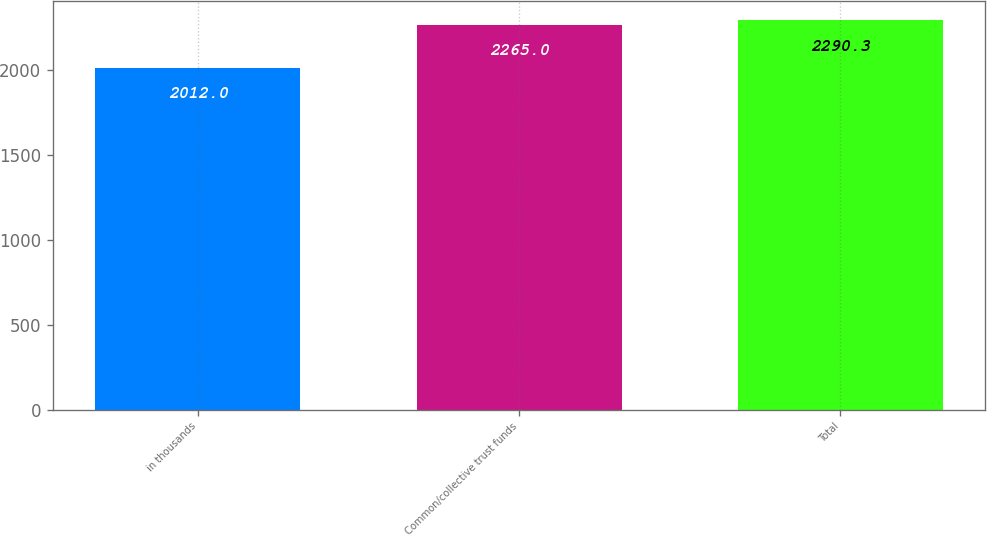<chart> <loc_0><loc_0><loc_500><loc_500><bar_chart><fcel>in thousands<fcel>Common/collective trust funds<fcel>Total<nl><fcel>2012<fcel>2265<fcel>2290.3<nl></chart> 